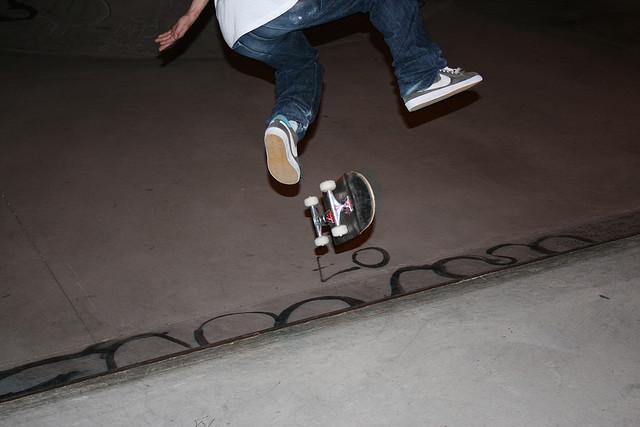How many wheels can you see in the picture?
Give a very brief answer. 4. How many of the motorcycles are blue?
Give a very brief answer. 0. 